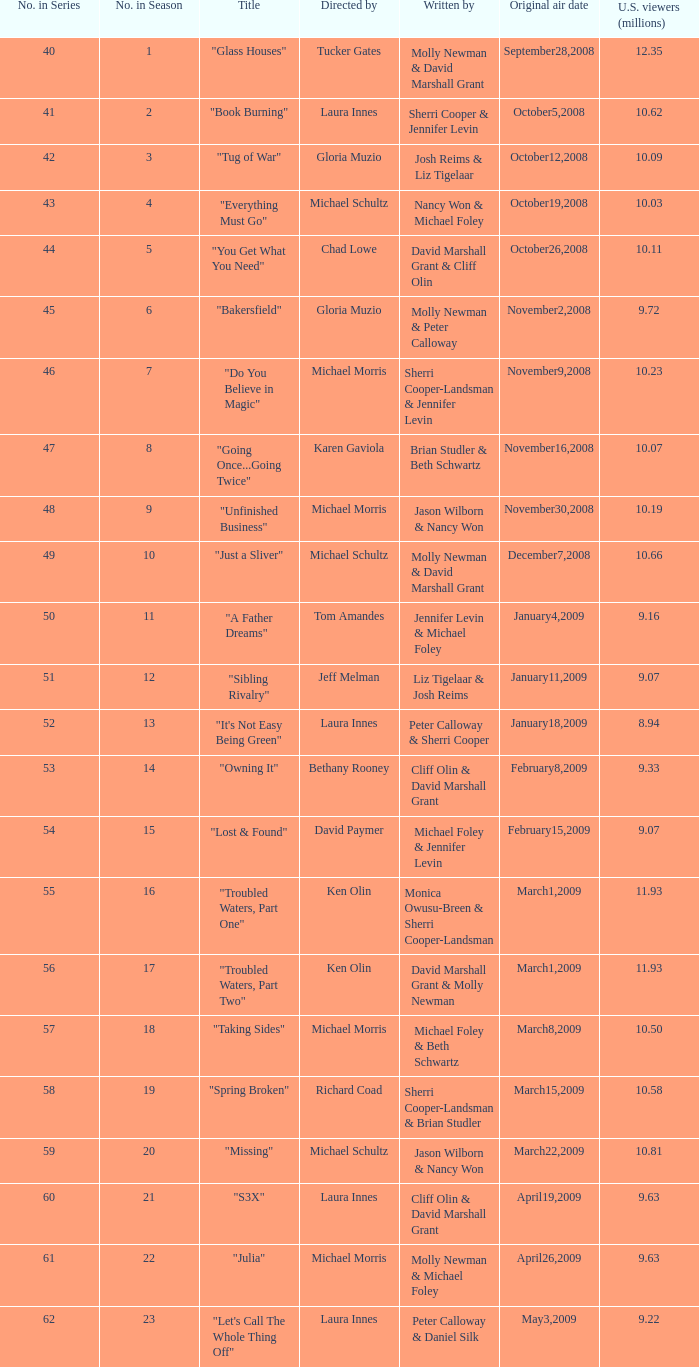63 million individuals in the us, directed by laura innes? "S3X". 